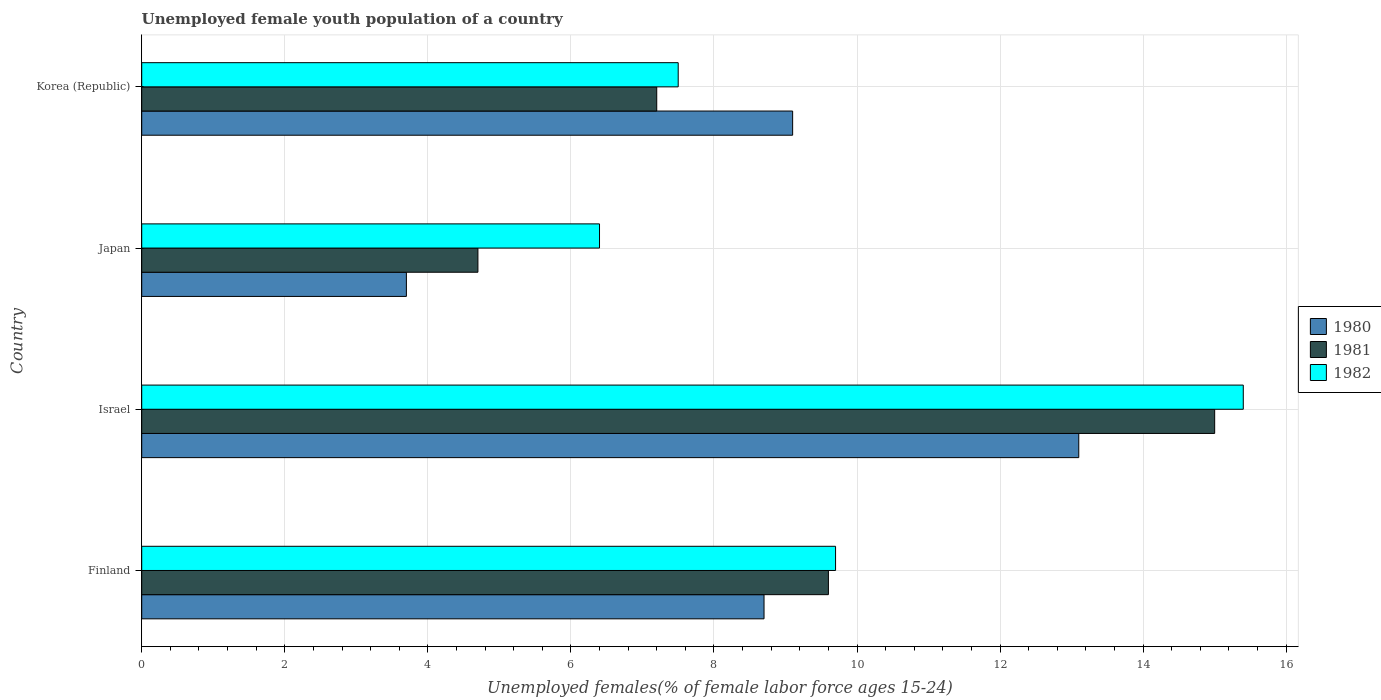How many different coloured bars are there?
Offer a very short reply. 3. Are the number of bars per tick equal to the number of legend labels?
Keep it short and to the point. Yes. Are the number of bars on each tick of the Y-axis equal?
Provide a succinct answer. Yes. How many bars are there on the 2nd tick from the bottom?
Your response must be concise. 3. What is the label of the 3rd group of bars from the top?
Ensure brevity in your answer.  Israel. Across all countries, what is the minimum percentage of unemployed female youth population in 1981?
Your answer should be compact. 4.7. What is the total percentage of unemployed female youth population in 1981 in the graph?
Offer a very short reply. 36.5. What is the difference between the percentage of unemployed female youth population in 1981 in Japan and that in Korea (Republic)?
Provide a succinct answer. -2.5. What is the difference between the percentage of unemployed female youth population in 1982 in Japan and the percentage of unemployed female youth population in 1981 in Finland?
Offer a very short reply. -3.2. What is the average percentage of unemployed female youth population in 1982 per country?
Your answer should be compact. 9.75. What is the difference between the percentage of unemployed female youth population in 1982 and percentage of unemployed female youth population in 1981 in Japan?
Your answer should be compact. 1.7. What is the ratio of the percentage of unemployed female youth population in 1980 in Israel to that in Korea (Republic)?
Offer a very short reply. 1.44. What is the difference between the highest and the second highest percentage of unemployed female youth population in 1982?
Ensure brevity in your answer.  5.7. What is the difference between the highest and the lowest percentage of unemployed female youth population in 1980?
Your response must be concise. 9.4. Is it the case that in every country, the sum of the percentage of unemployed female youth population in 1980 and percentage of unemployed female youth population in 1982 is greater than the percentage of unemployed female youth population in 1981?
Your response must be concise. Yes. How many bars are there?
Your response must be concise. 12. How many countries are there in the graph?
Provide a succinct answer. 4. Does the graph contain any zero values?
Ensure brevity in your answer.  No. Does the graph contain grids?
Your answer should be very brief. Yes. How many legend labels are there?
Your answer should be compact. 3. What is the title of the graph?
Provide a short and direct response. Unemployed female youth population of a country. Does "1966" appear as one of the legend labels in the graph?
Give a very brief answer. No. What is the label or title of the X-axis?
Ensure brevity in your answer.  Unemployed females(% of female labor force ages 15-24). What is the Unemployed females(% of female labor force ages 15-24) of 1980 in Finland?
Offer a very short reply. 8.7. What is the Unemployed females(% of female labor force ages 15-24) in 1981 in Finland?
Keep it short and to the point. 9.6. What is the Unemployed females(% of female labor force ages 15-24) in 1982 in Finland?
Keep it short and to the point. 9.7. What is the Unemployed females(% of female labor force ages 15-24) of 1980 in Israel?
Give a very brief answer. 13.1. What is the Unemployed females(% of female labor force ages 15-24) of 1982 in Israel?
Your answer should be compact. 15.4. What is the Unemployed females(% of female labor force ages 15-24) in 1980 in Japan?
Provide a succinct answer. 3.7. What is the Unemployed females(% of female labor force ages 15-24) in 1981 in Japan?
Your answer should be compact. 4.7. What is the Unemployed females(% of female labor force ages 15-24) in 1982 in Japan?
Keep it short and to the point. 6.4. What is the Unemployed females(% of female labor force ages 15-24) of 1980 in Korea (Republic)?
Provide a short and direct response. 9.1. What is the Unemployed females(% of female labor force ages 15-24) in 1981 in Korea (Republic)?
Make the answer very short. 7.2. Across all countries, what is the maximum Unemployed females(% of female labor force ages 15-24) of 1980?
Ensure brevity in your answer.  13.1. Across all countries, what is the maximum Unemployed females(% of female labor force ages 15-24) in 1981?
Your answer should be very brief. 15. Across all countries, what is the maximum Unemployed females(% of female labor force ages 15-24) of 1982?
Offer a terse response. 15.4. Across all countries, what is the minimum Unemployed females(% of female labor force ages 15-24) of 1980?
Provide a succinct answer. 3.7. Across all countries, what is the minimum Unemployed females(% of female labor force ages 15-24) of 1981?
Offer a terse response. 4.7. Across all countries, what is the minimum Unemployed females(% of female labor force ages 15-24) in 1982?
Your response must be concise. 6.4. What is the total Unemployed females(% of female labor force ages 15-24) of 1980 in the graph?
Your answer should be compact. 34.6. What is the total Unemployed females(% of female labor force ages 15-24) in 1981 in the graph?
Your answer should be very brief. 36.5. What is the difference between the Unemployed females(% of female labor force ages 15-24) of 1980 in Finland and that in Israel?
Ensure brevity in your answer.  -4.4. What is the difference between the Unemployed females(% of female labor force ages 15-24) in 1981 in Finland and that in Israel?
Provide a short and direct response. -5.4. What is the difference between the Unemployed females(% of female labor force ages 15-24) in 1982 in Finland and that in Israel?
Offer a terse response. -5.7. What is the difference between the Unemployed females(% of female labor force ages 15-24) in 1980 in Finland and that in Japan?
Offer a very short reply. 5. What is the difference between the Unemployed females(% of female labor force ages 15-24) of 1981 in Finland and that in Korea (Republic)?
Provide a short and direct response. 2.4. What is the difference between the Unemployed females(% of female labor force ages 15-24) in 1980 in Israel and that in Japan?
Your answer should be very brief. 9.4. What is the difference between the Unemployed females(% of female labor force ages 15-24) of 1982 in Israel and that in Japan?
Offer a terse response. 9. What is the difference between the Unemployed females(% of female labor force ages 15-24) in 1980 in Israel and that in Korea (Republic)?
Give a very brief answer. 4. What is the difference between the Unemployed females(% of female labor force ages 15-24) of 1982 in Japan and that in Korea (Republic)?
Your answer should be compact. -1.1. What is the difference between the Unemployed females(% of female labor force ages 15-24) in 1980 in Finland and the Unemployed females(% of female labor force ages 15-24) in 1982 in Israel?
Make the answer very short. -6.7. What is the difference between the Unemployed females(% of female labor force ages 15-24) in 1981 in Finland and the Unemployed females(% of female labor force ages 15-24) in 1982 in Israel?
Keep it short and to the point. -5.8. What is the difference between the Unemployed females(% of female labor force ages 15-24) of 1980 in Finland and the Unemployed females(% of female labor force ages 15-24) of 1981 in Japan?
Offer a terse response. 4. What is the difference between the Unemployed females(% of female labor force ages 15-24) of 1981 in Finland and the Unemployed females(% of female labor force ages 15-24) of 1982 in Japan?
Provide a succinct answer. 3.2. What is the difference between the Unemployed females(% of female labor force ages 15-24) in 1980 in Finland and the Unemployed females(% of female labor force ages 15-24) in 1981 in Korea (Republic)?
Keep it short and to the point. 1.5. What is the difference between the Unemployed females(% of female labor force ages 15-24) of 1980 in Finland and the Unemployed females(% of female labor force ages 15-24) of 1982 in Korea (Republic)?
Offer a terse response. 1.2. What is the difference between the Unemployed females(% of female labor force ages 15-24) of 1980 in Israel and the Unemployed females(% of female labor force ages 15-24) of 1981 in Japan?
Your response must be concise. 8.4. What is the difference between the Unemployed females(% of female labor force ages 15-24) in 1980 in Israel and the Unemployed females(% of female labor force ages 15-24) in 1982 in Japan?
Give a very brief answer. 6.7. What is the difference between the Unemployed females(% of female labor force ages 15-24) in 1980 in Israel and the Unemployed females(% of female labor force ages 15-24) in 1981 in Korea (Republic)?
Keep it short and to the point. 5.9. What is the difference between the Unemployed females(% of female labor force ages 15-24) in 1981 in Israel and the Unemployed females(% of female labor force ages 15-24) in 1982 in Korea (Republic)?
Your response must be concise. 7.5. What is the average Unemployed females(% of female labor force ages 15-24) of 1980 per country?
Offer a very short reply. 8.65. What is the average Unemployed females(% of female labor force ages 15-24) of 1981 per country?
Provide a short and direct response. 9.12. What is the average Unemployed females(% of female labor force ages 15-24) of 1982 per country?
Provide a short and direct response. 9.75. What is the difference between the Unemployed females(% of female labor force ages 15-24) of 1980 and Unemployed females(% of female labor force ages 15-24) of 1981 in Finland?
Offer a terse response. -0.9. What is the difference between the Unemployed females(% of female labor force ages 15-24) of 1980 and Unemployed females(% of female labor force ages 15-24) of 1982 in Finland?
Your answer should be compact. -1. What is the difference between the Unemployed females(% of female labor force ages 15-24) of 1981 and Unemployed females(% of female labor force ages 15-24) of 1982 in Finland?
Keep it short and to the point. -0.1. What is the difference between the Unemployed females(% of female labor force ages 15-24) of 1980 and Unemployed females(% of female labor force ages 15-24) of 1981 in Israel?
Provide a short and direct response. -1.9. What is the difference between the Unemployed females(% of female labor force ages 15-24) in 1980 and Unemployed females(% of female labor force ages 15-24) in 1982 in Japan?
Your answer should be very brief. -2.7. What is the difference between the Unemployed females(% of female labor force ages 15-24) in 1980 and Unemployed females(% of female labor force ages 15-24) in 1982 in Korea (Republic)?
Give a very brief answer. 1.6. What is the difference between the Unemployed females(% of female labor force ages 15-24) in 1981 and Unemployed females(% of female labor force ages 15-24) in 1982 in Korea (Republic)?
Offer a very short reply. -0.3. What is the ratio of the Unemployed females(% of female labor force ages 15-24) of 1980 in Finland to that in Israel?
Give a very brief answer. 0.66. What is the ratio of the Unemployed females(% of female labor force ages 15-24) in 1981 in Finland to that in Israel?
Give a very brief answer. 0.64. What is the ratio of the Unemployed females(% of female labor force ages 15-24) of 1982 in Finland to that in Israel?
Give a very brief answer. 0.63. What is the ratio of the Unemployed females(% of female labor force ages 15-24) of 1980 in Finland to that in Japan?
Keep it short and to the point. 2.35. What is the ratio of the Unemployed females(% of female labor force ages 15-24) in 1981 in Finland to that in Japan?
Your answer should be compact. 2.04. What is the ratio of the Unemployed females(% of female labor force ages 15-24) in 1982 in Finland to that in Japan?
Offer a very short reply. 1.52. What is the ratio of the Unemployed females(% of female labor force ages 15-24) of 1980 in Finland to that in Korea (Republic)?
Offer a terse response. 0.96. What is the ratio of the Unemployed females(% of female labor force ages 15-24) in 1982 in Finland to that in Korea (Republic)?
Your answer should be compact. 1.29. What is the ratio of the Unemployed females(% of female labor force ages 15-24) in 1980 in Israel to that in Japan?
Your response must be concise. 3.54. What is the ratio of the Unemployed females(% of female labor force ages 15-24) of 1981 in Israel to that in Japan?
Provide a succinct answer. 3.19. What is the ratio of the Unemployed females(% of female labor force ages 15-24) of 1982 in Israel to that in Japan?
Make the answer very short. 2.41. What is the ratio of the Unemployed females(% of female labor force ages 15-24) in 1980 in Israel to that in Korea (Republic)?
Ensure brevity in your answer.  1.44. What is the ratio of the Unemployed females(% of female labor force ages 15-24) of 1981 in Israel to that in Korea (Republic)?
Ensure brevity in your answer.  2.08. What is the ratio of the Unemployed females(% of female labor force ages 15-24) in 1982 in Israel to that in Korea (Republic)?
Your response must be concise. 2.05. What is the ratio of the Unemployed females(% of female labor force ages 15-24) of 1980 in Japan to that in Korea (Republic)?
Your response must be concise. 0.41. What is the ratio of the Unemployed females(% of female labor force ages 15-24) of 1981 in Japan to that in Korea (Republic)?
Make the answer very short. 0.65. What is the ratio of the Unemployed females(% of female labor force ages 15-24) of 1982 in Japan to that in Korea (Republic)?
Your answer should be very brief. 0.85. What is the difference between the highest and the lowest Unemployed females(% of female labor force ages 15-24) in 1981?
Your answer should be compact. 10.3. What is the difference between the highest and the lowest Unemployed females(% of female labor force ages 15-24) of 1982?
Ensure brevity in your answer.  9. 